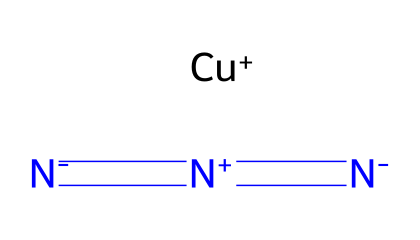How many nitrogen atoms are present in copper azide? The SMILES representation shows three nitrogen atoms connected by double bonds. The notation [N-]=[N+]=[N-] indicates there are three nitrogen atoms in total.
Answer: three What ion is present along with nitrogen in copper azide? In the SMILES representation, [Cu+] indicates the presence of a copper ion with a positive charge that is present alongside the nitrogen atoms of the azide.
Answer: copper ion What type of bonds do the nitrogen atoms share in copper azide? The representation [N-]=[N+]=[N-] indicates that the nitrogen atoms are sharing double bonds, as shown by the '=' signs.
Answer: double bonds What is the oxidation state of copper in this compound? The notation [Cu+] indicates that copper has a +1 oxidation state in copper azide, as shown by the positive charge next to it.
Answer: +1 How many total atoms are present in copper azide? The chemical contains one copper atom and three nitrogen atoms. Therefore, the total number of atoms is 1 (Cu) + 3 (N) = 4.
Answer: four What is the overall charge of copper azide? The copper ion has a +1 charge, and the three nitrogen atoms have a total charge of -1 (N3). Thus, the overall charge of the compound is +1 + (-1) = 0, making it neutral.
Answer: neutral What functional group is characteristic of azides in this structure? The structure has the azide functional group characterized by the three nitrogen atoms connected with the specific bond arrangement (N=N=N), indicating the presence of azides.
Answer: azide functional group 